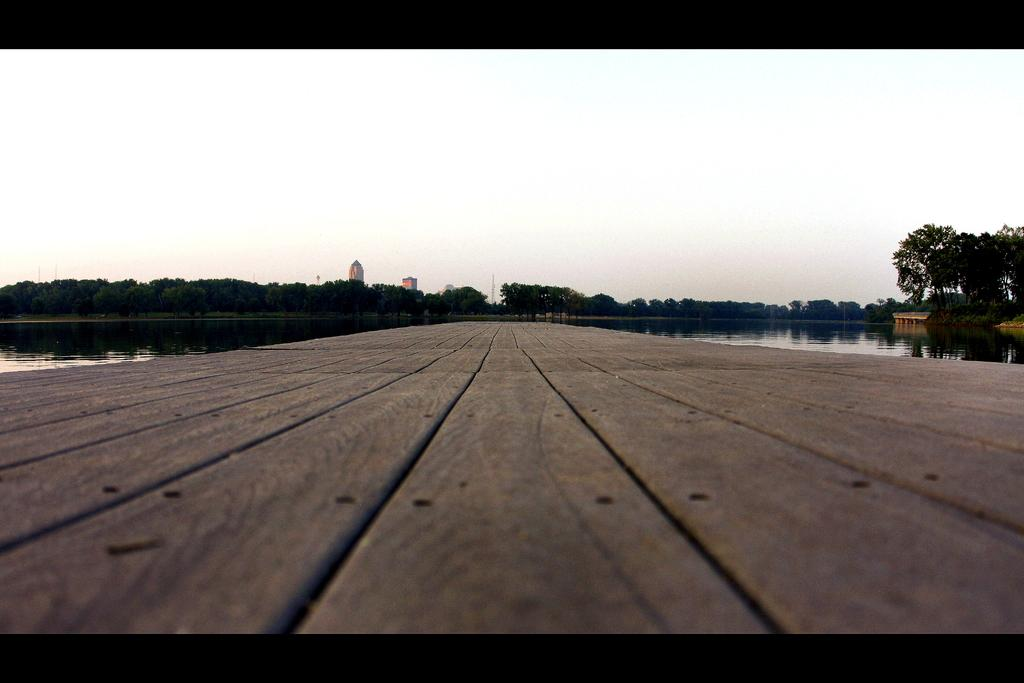What structure can be seen crossing over water in the image? There is a bridge in the image that crosses over water. What type of natural environment is visible near the bridge? There are trees in the image. What type of man-made structures can be seen in the image? There are buildings in the image. What is visible above the bridge and the surrounding environment? The sky is visible in the image. How many hearts can be seen in the image? There are no hearts visible in the image. What type of sticks are used to support the bridge in the image? The image does not show the bridge's support structure, so it is not possible to determine if any sticks are used. 